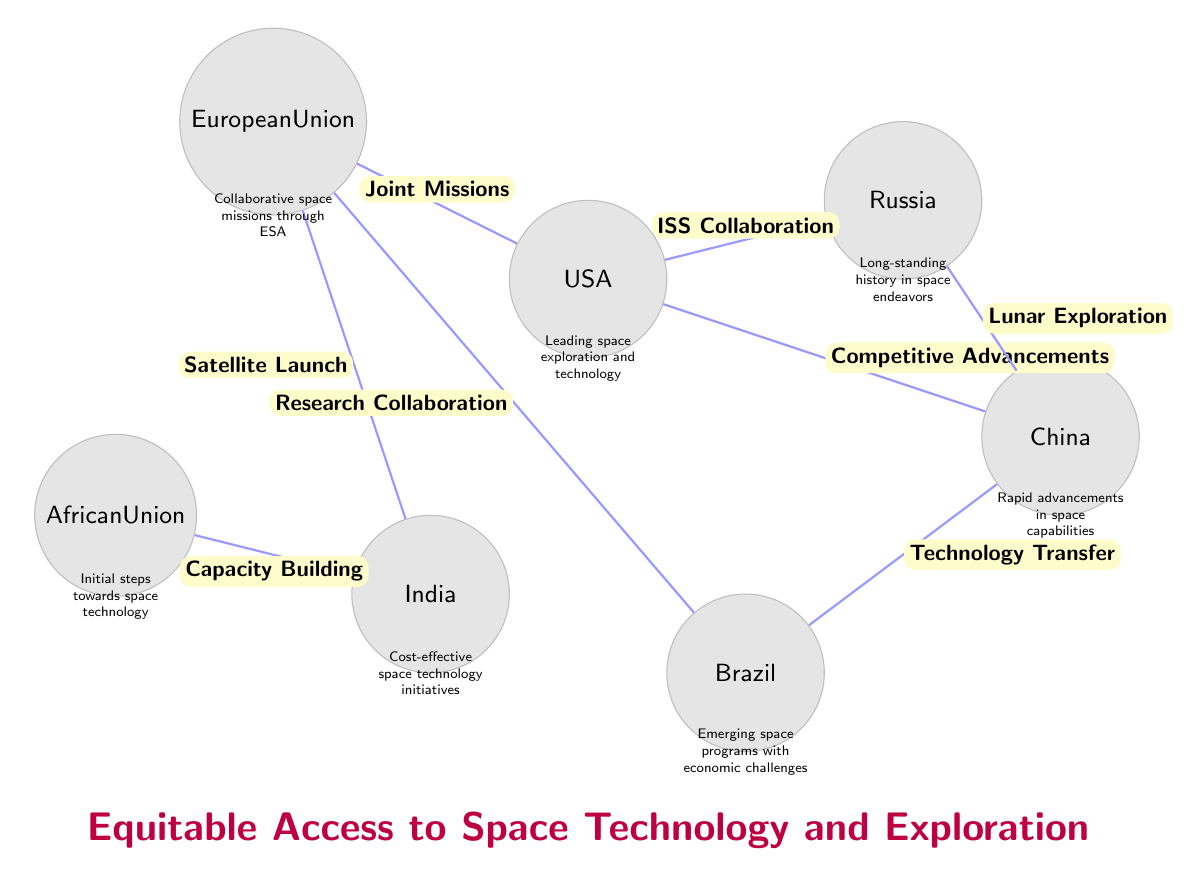What are the main countries represented in the diagram? The diagram showcases several countries including the USA, Russia, China, India, the European Union, Brazil, and the African Union, each depicted as a planet.
Answer: USA, Russia, China, India, European Union, Brazil, African Union How many connections are there in the diagram? By counting the lines representing collaborations and relationships between the countries (connections), we find there are a total of 7 connections.
Answer: 7 What type of collaboration is shown between the USA and Russia? The diagram states that the collaboration between the USA and Russia is labeled as "ISS Collaboration," indicating a partnership involving the International Space Station.
Answer: ISS Collaboration Which entity is described as having "initial steps towards space technology"? The African Union, indicated near the bottom-left of the diagram, has the description "Initial steps towards space technology," suggesting it is in the early stages of engagement in this field.
Answer: African Union What is the primary focus of space initiatives for India? According to the diagram, India is noted for having "Cost-effective space technology initiatives," highlighting its approach to affordable solutions in space exploration and technology.
Answer: Cost-effective space technology initiatives What collaborative efforts are indicated between China and Brazil? The connection between China and Brazil is marked as "Technology Transfer," which implies that China provides technological expertise or capabilities to Brazil.
Answer: Technology Transfer Which country is depicted as the leader in space exploration efforts? The United States, highlighted at the center-top of the diagram with the description “Leading space exploration and technology,” is identified as the foremost country in this domain.
Answer: USA Which two entities are connected through "Capacity Building"? The diagram shows that India connects with the African Union through "Capacity Building," suggesting that India helps enhance skills or infrastructure in the African Union regarding space technology.
Answer: India and African Union 